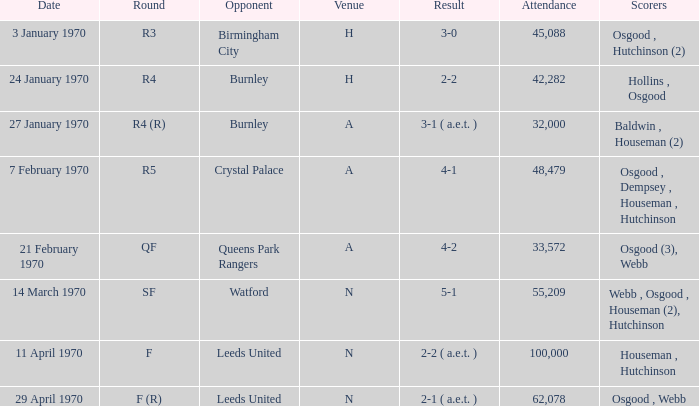Write the full table. {'header': ['Date', 'Round', 'Opponent', 'Venue', 'Result', 'Attendance', 'Scorers'], 'rows': [['3 January 1970', 'R3', 'Birmingham City', 'H', '3-0', '45,088', 'Osgood , Hutchinson (2)'], ['24 January 1970', 'R4', 'Burnley', 'H', '2-2', '42,282', 'Hollins , Osgood'], ['27 January 1970', 'R4 (R)', 'Burnley', 'A', '3-1 ( a.e.t. )', '32,000', 'Baldwin , Houseman (2)'], ['7 February 1970', 'R5', 'Crystal Palace', 'A', '4-1', '48,479', 'Osgood , Dempsey , Houseman , Hutchinson'], ['21 February 1970', 'QF', 'Queens Park Rangers', 'A', '4-2', '33,572', 'Osgood (3), Webb'], ['14 March 1970', 'SF', 'Watford', 'N', '5-1', '55,209', 'Webb , Osgood , Houseman (2), Hutchinson'], ['11 April 1970', 'F', 'Leeds United', 'N', '2-2 ( a.e.t. )', '100,000', 'Houseman , Hutchinson'], ['29 April 1970', 'F (R)', 'Leeds United', 'N', '2-1 ( a.e.t. )', '62,078', 'Osgood , Webb']]} During which round was the match with watford played? SF. 